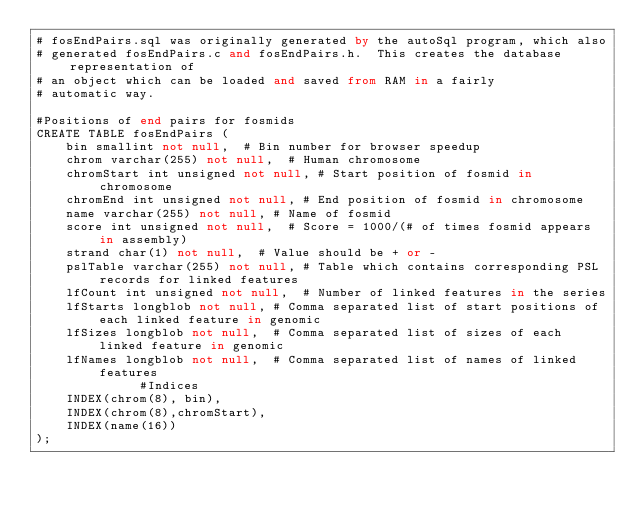Convert code to text. <code><loc_0><loc_0><loc_500><loc_500><_SQL_># fosEndPairs.sql was originally generated by the autoSql program, which also 
# generated fosEndPairs.c and fosEndPairs.h.  This creates the database representation of
# an object which can be loaded and saved from RAM in a fairly 
# automatic way.

#Positions of end pairs for fosmids
CREATE TABLE fosEndPairs (
    bin smallint not null,	# Bin number for browser speedup
    chrom varchar(255) not null,	# Human chromosome
    chromStart int unsigned not null,	# Start position of fosmid in chromosome
    chromEnd int unsigned not null,	# End position of fosmid in chromosome
    name varchar(255) not null,	# Name of fosmid
    score int unsigned not null,	# Score = 1000/(# of times fosmid appears in assembly)
    strand char(1) not null,	# Value should be + or -
    pslTable varchar(255) not null,	# Table which contains corresponding PSL records for linked features
    lfCount int unsigned not null,	# Number of linked features in the series
    lfStarts longblob not null,	# Comma separated list of start positions of each linked feature in genomic
    lfSizes longblob not null,	# Comma separated list of sizes of each linked feature in genomic
    lfNames longblob not null,	# Comma separated list of names of linked features
              #Indices
    INDEX(chrom(8), bin),
    INDEX(chrom(8),chromStart),
    INDEX(name(16))
);

</code> 